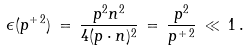<formula> <loc_0><loc_0><loc_500><loc_500>\epsilon ( p ^ { + \, 2 } ) \, = \, \frac { p ^ { 2 } n ^ { 2 } } { 4 ( p \cdot n ) ^ { 2 } } \, = \, \frac { p ^ { 2 } } { p ^ { + \, 2 } } \, \ll \, 1 \, .</formula> 